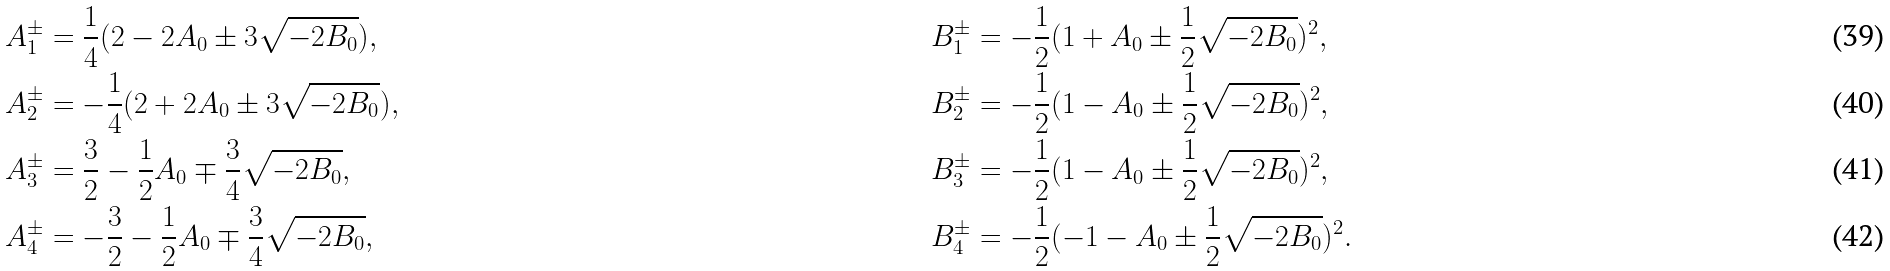<formula> <loc_0><loc_0><loc_500><loc_500>A _ { 1 } ^ { \pm } & = \frac { 1 } { 4 } ( 2 - 2 A _ { 0 } \pm 3 \sqrt { - 2 B _ { 0 } } ) , & B _ { 1 } ^ { \pm } & = - \frac { 1 } { 2 } ( 1 + A _ { 0 } \pm \frac { 1 } { 2 } \sqrt { - 2 B _ { 0 } } ) ^ { 2 } , \\ A _ { 2 } ^ { \pm } & = - \frac { 1 } { 4 } ( 2 + 2 A _ { 0 } \pm 3 \sqrt { - 2 B _ { 0 } } ) , & B _ { 2 } ^ { \pm } & = - \frac { 1 } { 2 } ( 1 - A _ { 0 } \pm \frac { 1 } { 2 } \sqrt { - 2 B _ { 0 } } ) ^ { 2 } , \\ A _ { 3 } ^ { \pm } & = \frac { 3 } { 2 } - \frac { 1 } { 2 } A _ { 0 } \mp \frac { 3 } { 4 } \sqrt { - 2 B _ { 0 } } , & B _ { 3 } ^ { \pm } & = - \frac { 1 } { 2 } ( 1 - A _ { 0 } \pm \frac { 1 } { 2 } \sqrt { - 2 B _ { 0 } } ) ^ { 2 } , \\ A _ { 4 } ^ { \pm } & = - \frac { 3 } { 2 } - \frac { 1 } { 2 } A _ { 0 } \mp \frac { 3 } { 4 } \sqrt { - 2 B _ { 0 } } , & B _ { 4 } ^ { \pm } & = - \frac { 1 } { 2 } ( - 1 - A _ { 0 } \pm \frac { 1 } { 2 } \sqrt { - 2 B _ { 0 } } ) ^ { 2 } .</formula> 